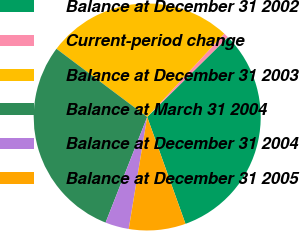Convert chart to OTSL. <chart><loc_0><loc_0><loc_500><loc_500><pie_chart><fcel>Balance at December 31 2002<fcel>Current-period change<fcel>Balance at December 31 2003<fcel>Balance at March 31 2004<fcel>Balance at December 31 2004<fcel>Balance at December 31 2005<nl><fcel>31.94%<fcel>0.71%<fcel>26.62%<fcel>29.28%<fcel>3.37%<fcel>8.08%<nl></chart> 